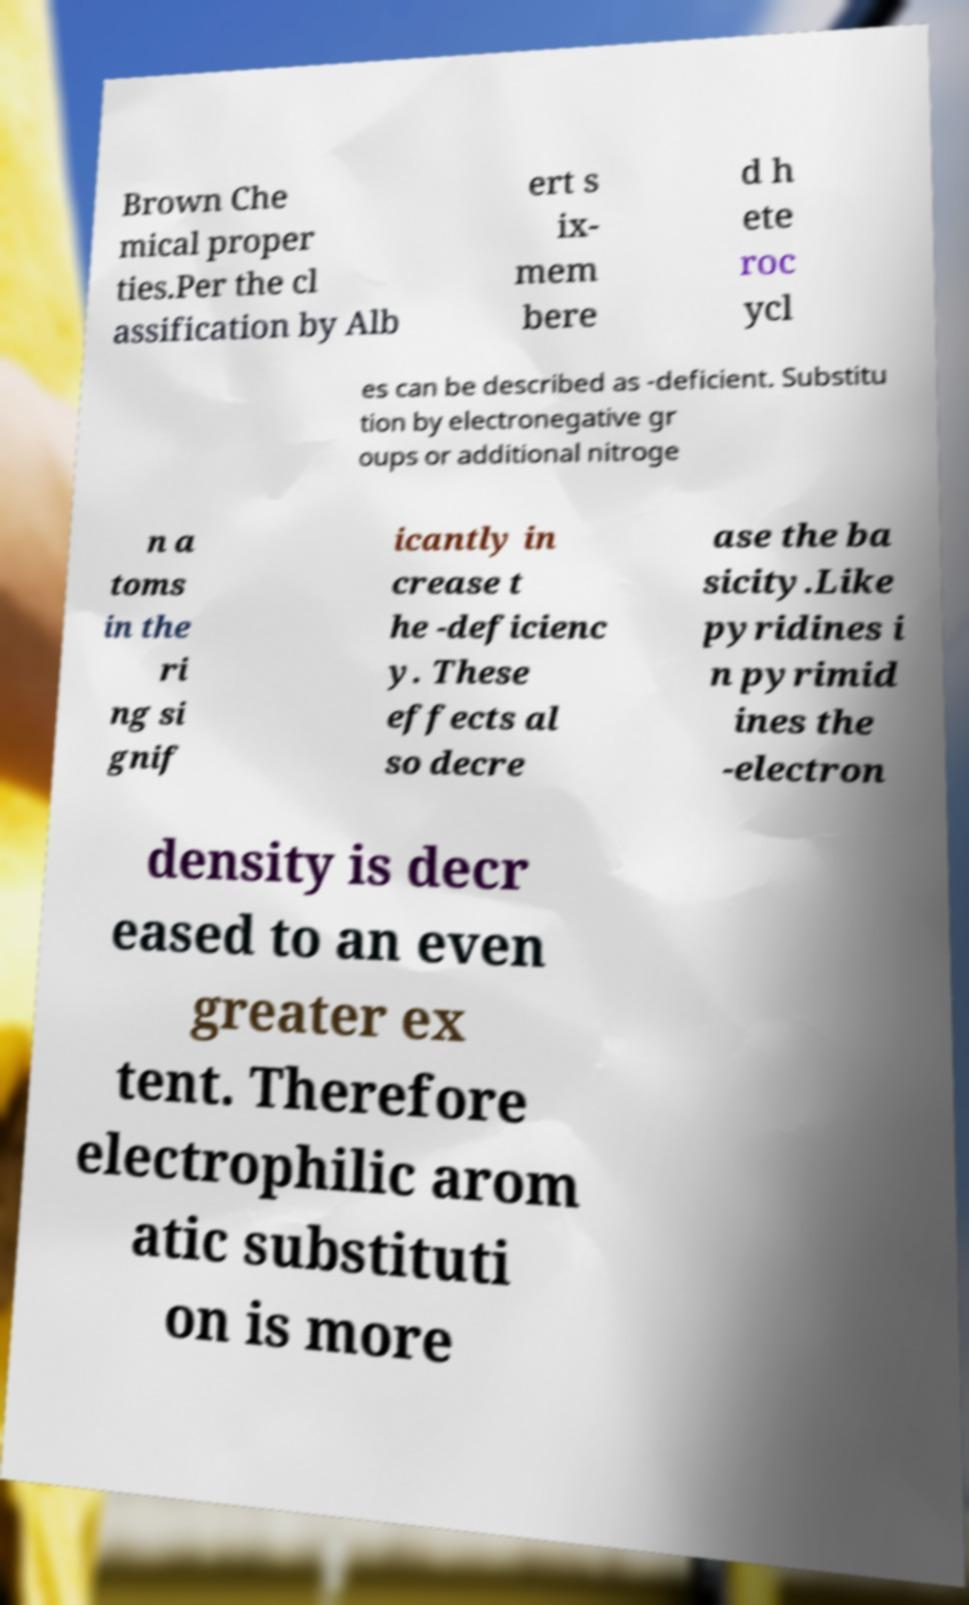Could you extract and type out the text from this image? Brown Che mical proper ties.Per the cl assification by Alb ert s ix- mem bere d h ete roc ycl es can be described as -deficient. Substitu tion by electronegative gr oups or additional nitroge n a toms in the ri ng si gnif icantly in crease t he -deficienc y. These effects al so decre ase the ba sicity.Like pyridines i n pyrimid ines the -electron density is decr eased to an even greater ex tent. Therefore electrophilic arom atic substituti on is more 